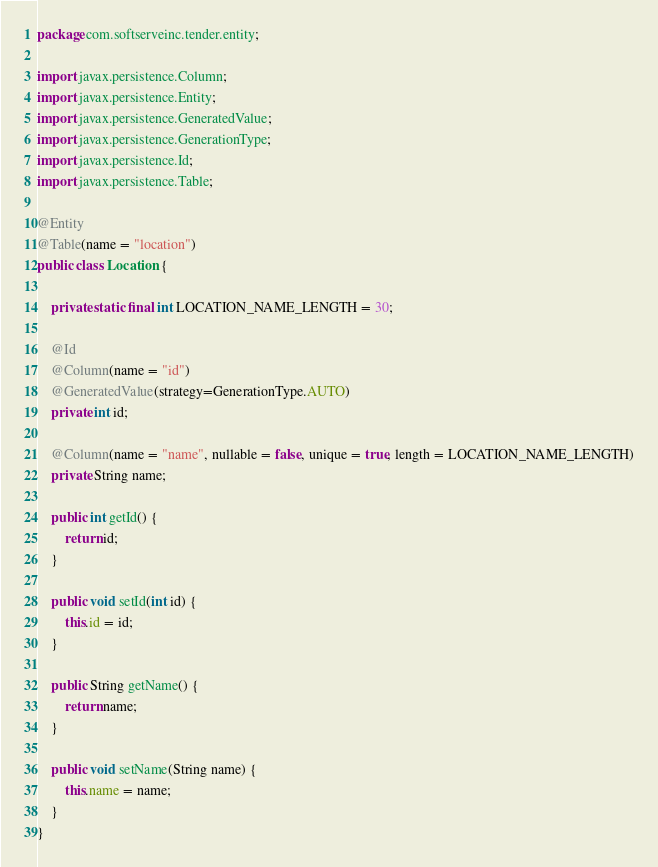<code> <loc_0><loc_0><loc_500><loc_500><_Java_>package com.softserveinc.tender.entity;

import javax.persistence.Column;
import javax.persistence.Entity;
import javax.persistence.GeneratedValue;
import javax.persistence.GenerationType;
import javax.persistence.Id;
import javax.persistence.Table;

@Entity
@Table(name = "location")
public class Location {

    private static final int LOCATION_NAME_LENGTH = 30;

    @Id
    @Column(name = "id")
    @GeneratedValue(strategy=GenerationType.AUTO)
    private int id;

    @Column(name = "name", nullable = false, unique = true, length = LOCATION_NAME_LENGTH)
    private String name;

    public int getId() {
        return id;
    }

    public void setId(int id) {
        this.id = id;
    }

    public String getName() {
        return name;
    }

    public void setName(String name) {
        this.name = name;
    }
}</code> 